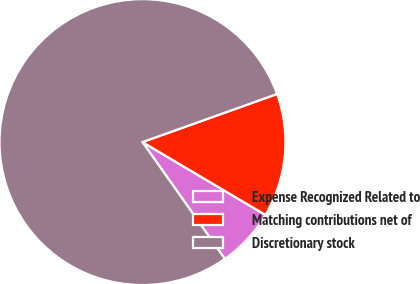<chart> <loc_0><loc_0><loc_500><loc_500><pie_chart><fcel>Expense Recognized Related to<fcel>Matching contributions net of<fcel>Discretionary stock<nl><fcel>6.71%<fcel>13.97%<fcel>79.31%<nl></chart> 